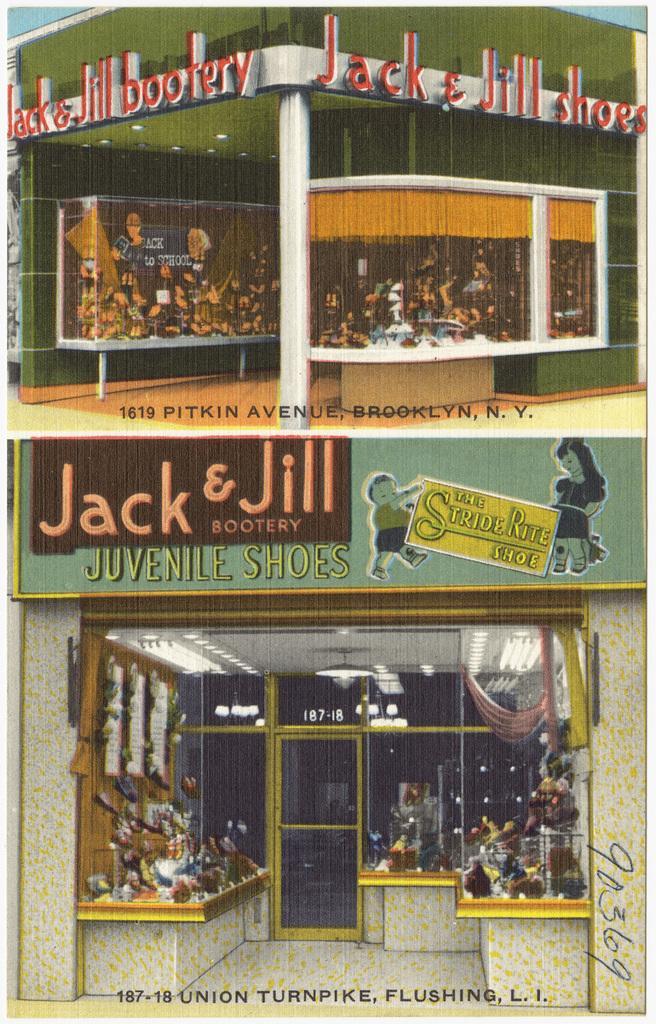How would you summarize this image in a sentence or two? In the picture we can see a magazine of the painting of the building with a shop to it and in the shop we can see some desks with some things are placed on it and with a glass door and on it jack and Jill bootary. 